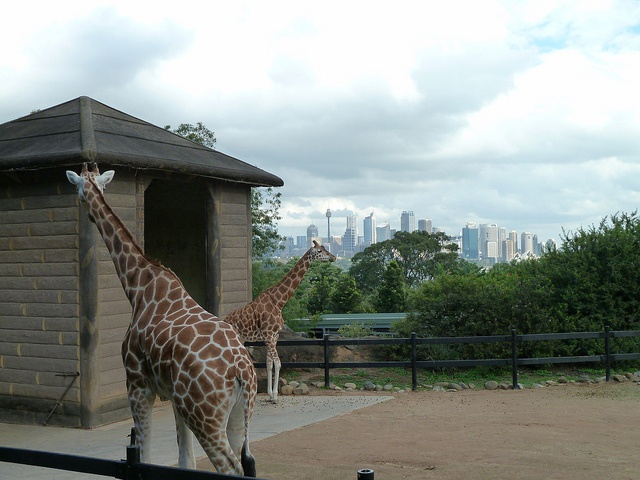Describe the objects in this image and their specific colors. I can see giraffe in white, gray, black, and maroon tones and giraffe in white, gray, maroon, and black tones in this image. 